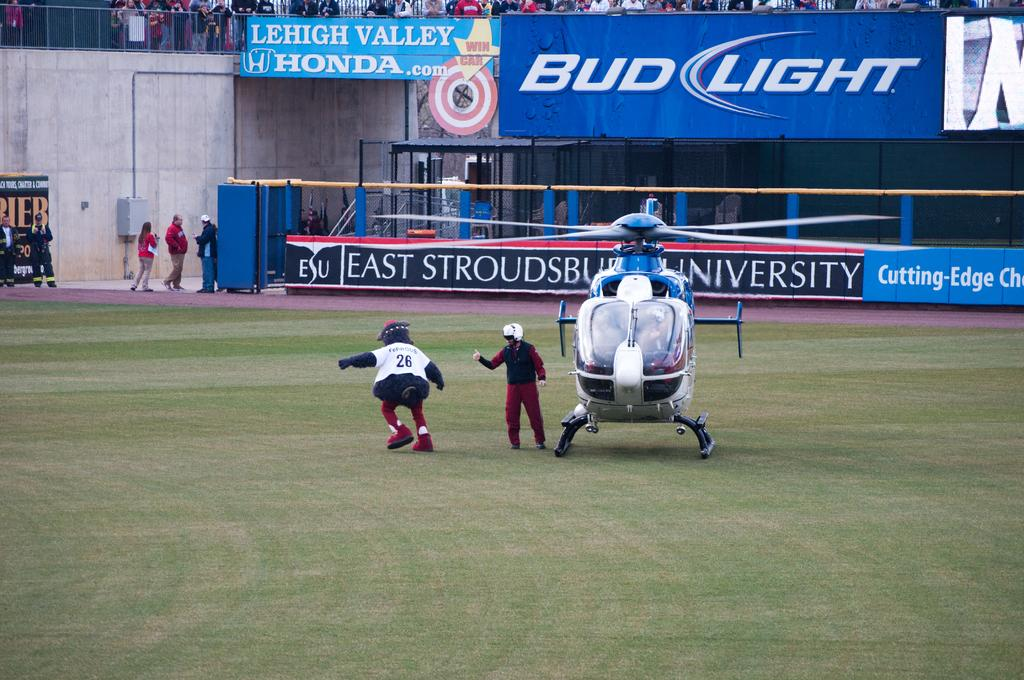<image>
Give a short and clear explanation of the subsequent image. A sports field with an advertisement for Bud Light 